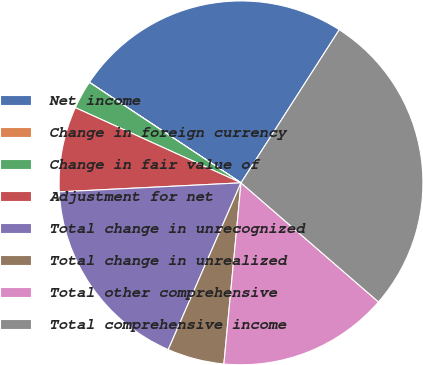Convert chart to OTSL. <chart><loc_0><loc_0><loc_500><loc_500><pie_chart><fcel>Net income<fcel>Change in foreign currency<fcel>Change in fair value of<fcel>Adjustment for net<fcel>Total change in unrecognized<fcel>Total change in unrealized<fcel>Total other comprehensive<fcel>Total comprehensive income<nl><fcel>24.76%<fcel>0.01%<fcel>2.53%<fcel>7.57%<fcel>17.66%<fcel>5.05%<fcel>15.14%<fcel>27.28%<nl></chart> 